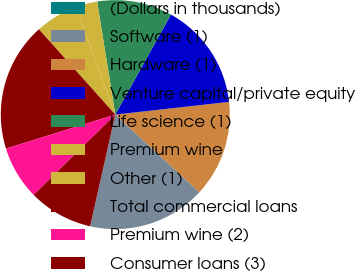Convert chart. <chart><loc_0><loc_0><loc_500><loc_500><pie_chart><fcel>(Dollars in thousands)<fcel>Software (1)<fcel>Hardware (1)<fcel>Venture capital/private equity<fcel>Life science (1)<fcel>Premium wine<fcel>Other (1)<fcel>Total commercial loans<fcel>Premium wine (2)<fcel>Consumer loans (3)<nl><fcel>0.0%<fcel>16.66%<fcel>13.64%<fcel>15.15%<fcel>10.61%<fcel>3.03%<fcel>6.06%<fcel>18.18%<fcel>7.58%<fcel>9.09%<nl></chart> 